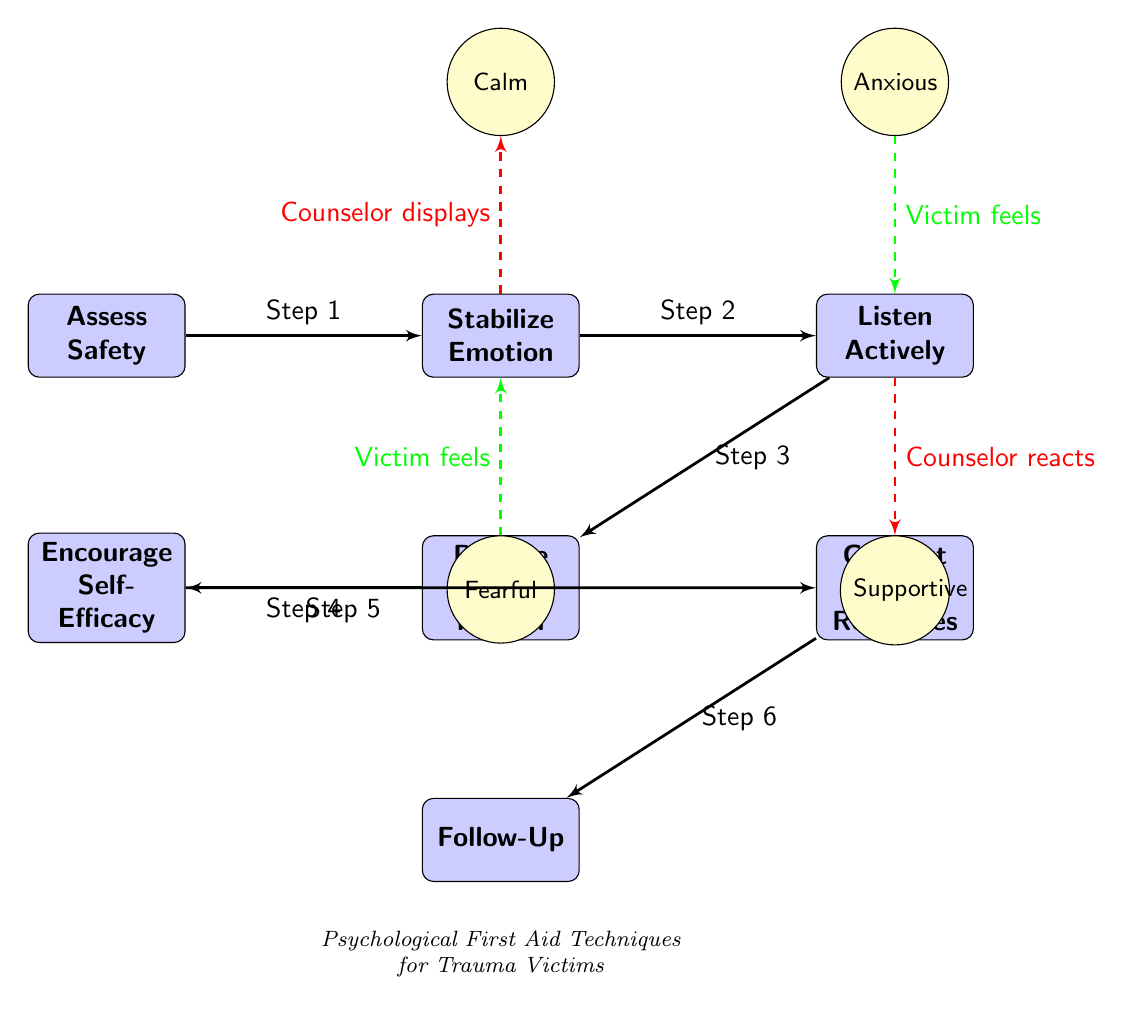What is the first step in the diagram? The first step in the diagram is indicated as "Assess Safety," and it is the leftmost block in the series of steps.
Answer: Assess Safety How many emotional states are represented in the diagram? There are four emotional states represented in the diagram, as indicated by the icons above and below the steps.
Answer: 4 What type of response does the counselor display when stabilizing emotion? The emotional state represented above the "Stabilize Emotion" block is "Calm," indicating the counselor's response during this step.
Answer: Calm Which step follows "Provide Information"? The step that directly follows "Provide Information" is "Encourage Self-Efficacy," indicated by the arrow leading to it from the left.
Answer: Encourage Self-Efficacy What emotional state does the victim feel when the counselor listens actively? The emotional state indicated next to the "Listen Actively" block is "Anxious," which reflects what the victim feels during this step.
Answer: Anxious What is the last step in the sequence of psychological first aid techniques? The last step in the sequence, as indicated at the bottom right of the diagram, is "Follow-Up."
Answer: Follow-Up How is the connection between "Encourage Self-Efficacy" and "Connect with Resources" represented? The connection between these two steps is represented with a line that shows that "Encourage Self-Efficacy" leads to a midpoint between itself and "Connect with Resources."
Answer: Midpoint connection What does the counselor react with when the victim feels fearful? When the victim feels fearful, the counselor reacts with "Calm," as indicated by the dashed line connecting these two emotions in the diagram.
Answer: Calm Which step comes after "Stabilize Emotion"? The step that follows "Stabilize Emotion" is "Listen Actively," as shown by the progression in the diagram following the connections between the blocks.
Answer: Listen Actively 